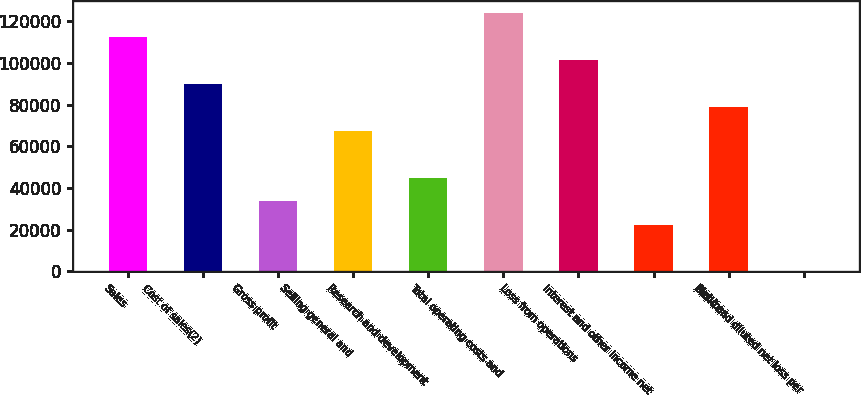Convert chart to OTSL. <chart><loc_0><loc_0><loc_500><loc_500><bar_chart><fcel>Sales<fcel>Cost of sales(2)<fcel>Gross profit<fcel>Selling general and<fcel>Research and development<fcel>Total operating costs and<fcel>Loss from operations<fcel>Interest and other income net<fcel>Net loss<fcel>Basic and diluted net loss per<nl><fcel>112421<fcel>89937.1<fcel>33727.4<fcel>67453.2<fcel>44969.3<fcel>123663<fcel>101179<fcel>22485.4<fcel>78695.1<fcel>1.56<nl></chart> 